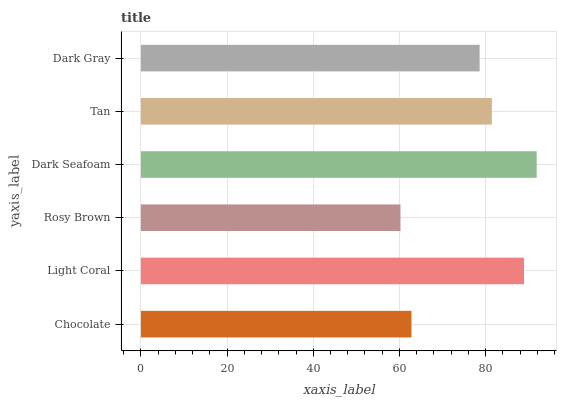Is Rosy Brown the minimum?
Answer yes or no. Yes. Is Dark Seafoam the maximum?
Answer yes or no. Yes. Is Light Coral the minimum?
Answer yes or no. No. Is Light Coral the maximum?
Answer yes or no. No. Is Light Coral greater than Chocolate?
Answer yes or no. Yes. Is Chocolate less than Light Coral?
Answer yes or no. Yes. Is Chocolate greater than Light Coral?
Answer yes or no. No. Is Light Coral less than Chocolate?
Answer yes or no. No. Is Tan the high median?
Answer yes or no. Yes. Is Dark Gray the low median?
Answer yes or no. Yes. Is Light Coral the high median?
Answer yes or no. No. Is Dark Seafoam the low median?
Answer yes or no. No. 